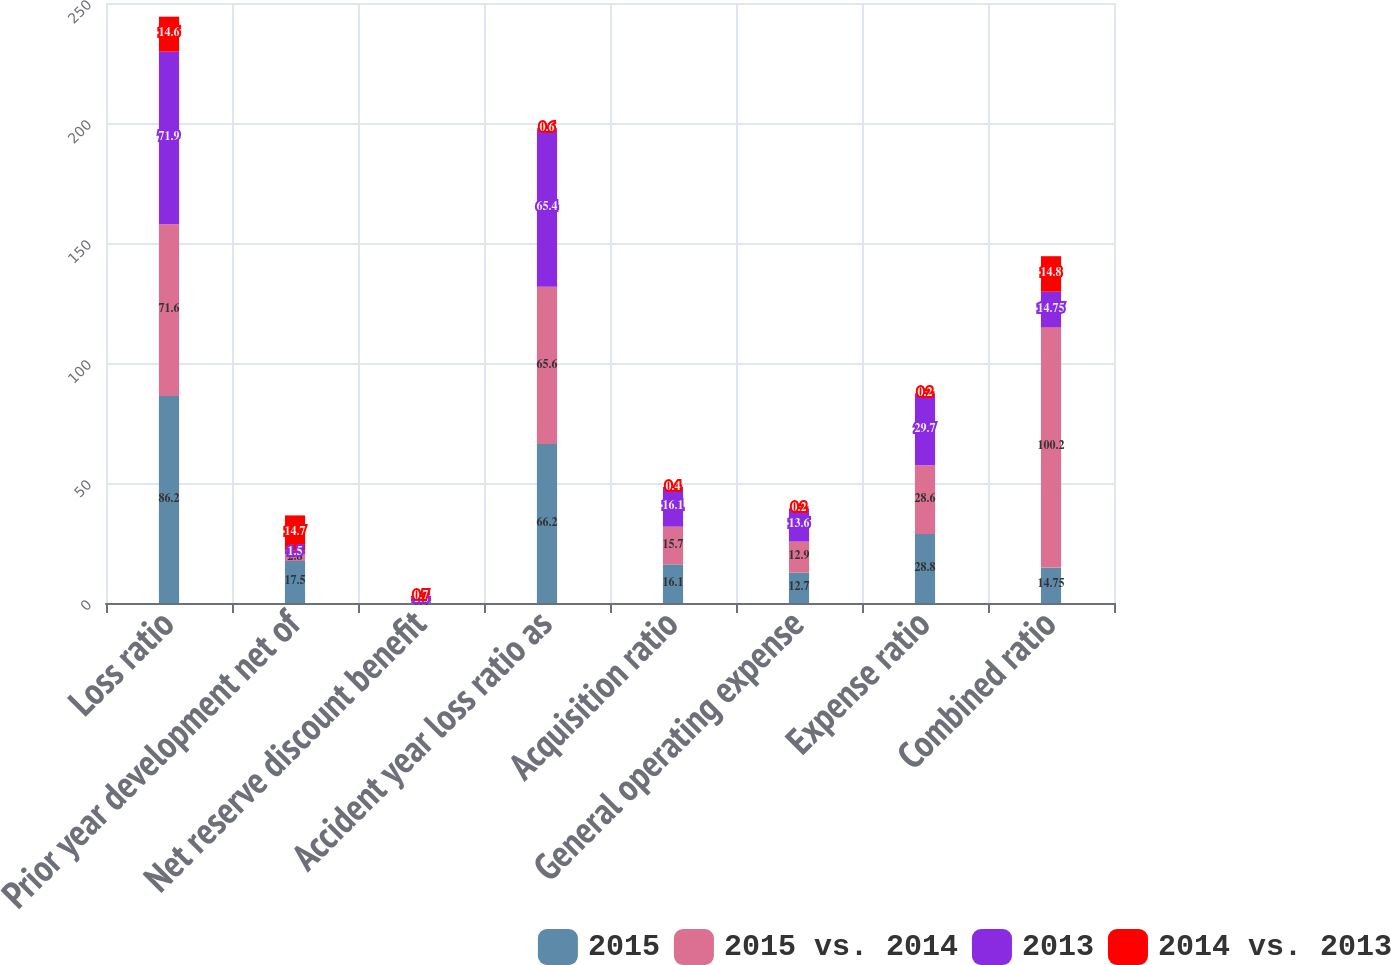Convert chart. <chart><loc_0><loc_0><loc_500><loc_500><stacked_bar_chart><ecel><fcel>Loss ratio<fcel>Prior year development net of<fcel>Net reserve discount benefit<fcel>Accident year loss ratio as<fcel>Acquisition ratio<fcel>General operating expense<fcel>Expense ratio<fcel>Combined ratio<nl><fcel>2015<fcel>86.2<fcel>17.5<fcel>0.4<fcel>66.2<fcel>16.1<fcel>12.7<fcel>28.8<fcel>14.75<nl><fcel>2015 vs. 2014<fcel>71.6<fcel>2.8<fcel>0.3<fcel>65.6<fcel>15.7<fcel>12.9<fcel>28.6<fcel>100.2<nl><fcel>2013<fcel>71.9<fcel>1.5<fcel>1.6<fcel>65.4<fcel>16.1<fcel>13.6<fcel>29.7<fcel>14.75<nl><fcel>2014 vs. 2013<fcel>14.6<fcel>14.7<fcel>0.7<fcel>0.6<fcel>0.4<fcel>0.2<fcel>0.2<fcel>14.8<nl></chart> 